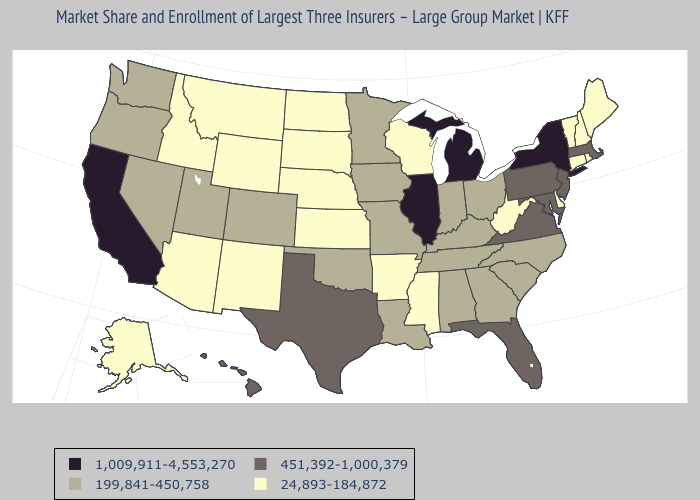What is the highest value in states that border Delaware?
Give a very brief answer. 451,392-1,000,379. What is the value of Hawaii?
Short answer required. 451,392-1,000,379. What is the lowest value in the South?
Keep it brief. 24,893-184,872. How many symbols are there in the legend?
Keep it brief. 4. What is the value of Virginia?
Keep it brief. 451,392-1,000,379. Name the states that have a value in the range 199,841-450,758?
Give a very brief answer. Alabama, Colorado, Georgia, Indiana, Iowa, Kentucky, Louisiana, Minnesota, Missouri, Nevada, North Carolina, Ohio, Oklahoma, Oregon, South Carolina, Tennessee, Utah, Washington. Which states have the lowest value in the USA?
Short answer required. Alaska, Arizona, Arkansas, Connecticut, Delaware, Idaho, Kansas, Maine, Mississippi, Montana, Nebraska, New Hampshire, New Mexico, North Dakota, Rhode Island, South Dakota, Vermont, West Virginia, Wisconsin, Wyoming. Which states have the lowest value in the West?
Be succinct. Alaska, Arizona, Idaho, Montana, New Mexico, Wyoming. What is the lowest value in states that border New Mexico?
Write a very short answer. 24,893-184,872. How many symbols are there in the legend?
Concise answer only. 4. What is the lowest value in states that border Illinois?
Short answer required. 24,893-184,872. Does the map have missing data?
Keep it brief. No. Does Oregon have a lower value than Virginia?
Quick response, please. Yes. What is the value of Nebraska?
Write a very short answer. 24,893-184,872. 